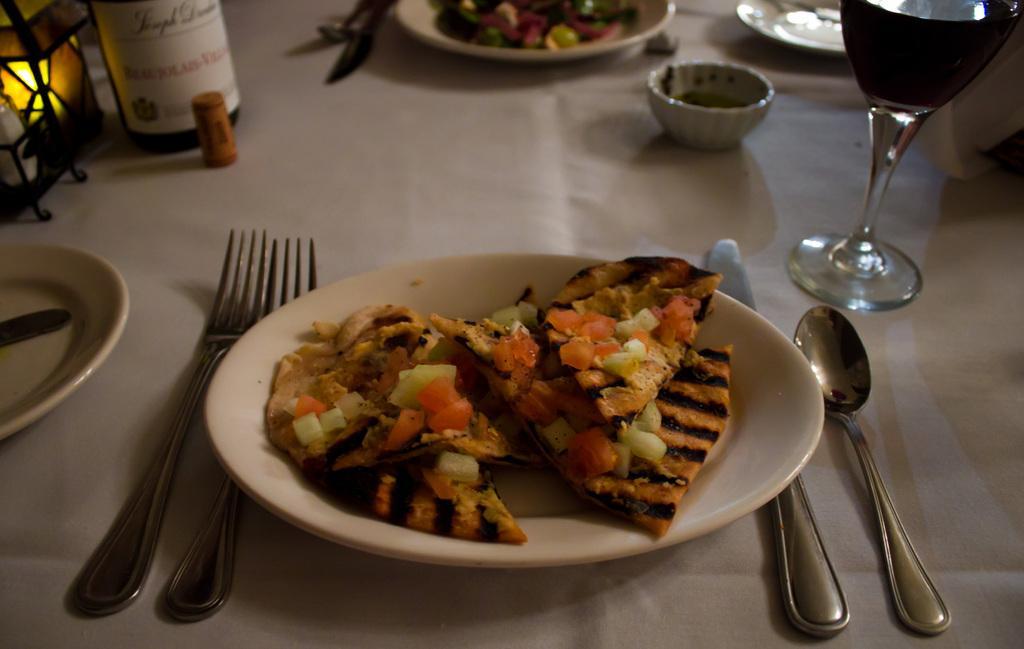Describe this image in one or two sentences. This image consists of a plate. On that there are some eatables. There are plates at the top. There is glass on the right side. There is bottled at the top. There are forks in the middle. There is spoon, knife, plate in the middle. 